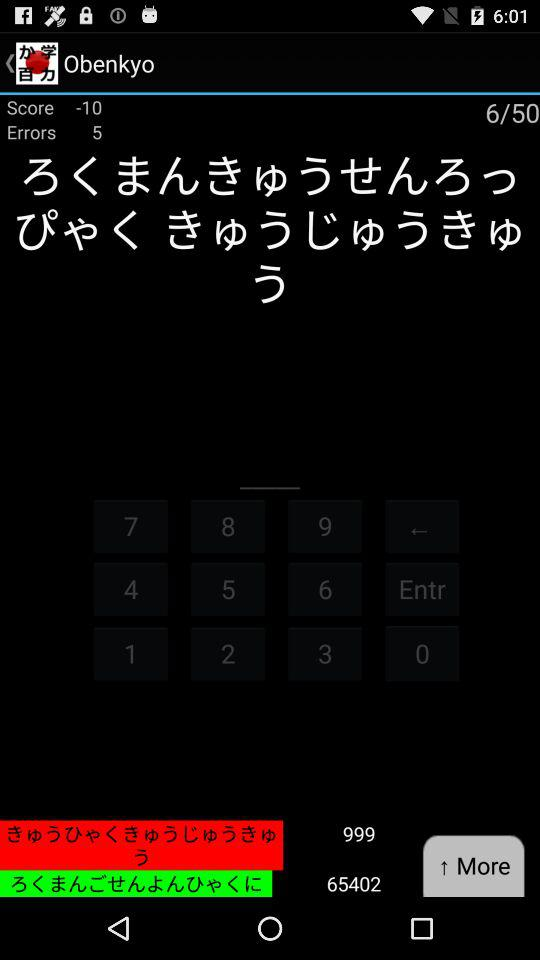What is the total score of the lesson?
Answer the question using a single word or phrase. 65402 